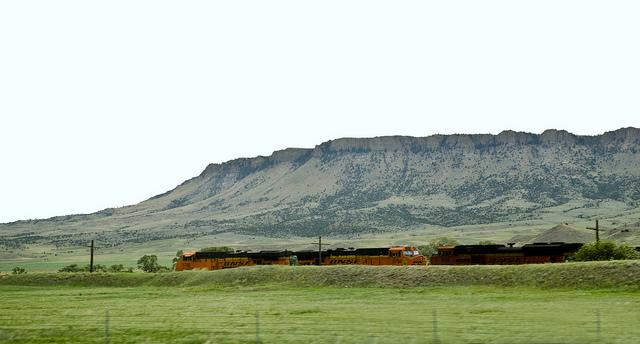What direction is the train heading?
Be succinct. Left. Are there animals in this image?
Give a very brief answer. No. Is there any animals in the picture?
Quick response, please. No. What are the 2 red things?
Give a very brief answer. Trains. What do the yellow tags represent?
Quick response, please. Nothing. Is there any snow on the hills?
Short answer required. No. Is this a commuter train?
Keep it brief. No. 